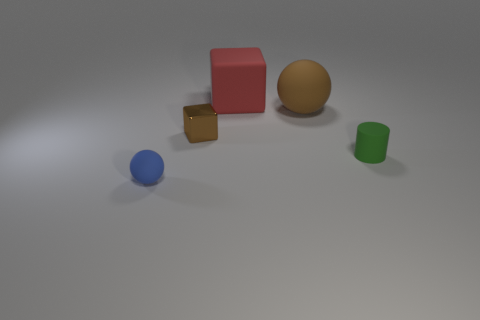Add 3 spheres. How many objects exist? 8 Subtract all red blocks. How many blocks are left? 1 Subtract 1 cubes. How many cubes are left? 1 Subtract all blocks. How many objects are left? 3 Subtract all blue cylinders. Subtract all brown balls. How many cylinders are left? 1 Subtract all tiny blue rubber things. Subtract all big gray spheres. How many objects are left? 4 Add 3 tiny blue things. How many tiny blue things are left? 4 Add 2 tiny green shiny cubes. How many tiny green shiny cubes exist? 2 Subtract 0 green blocks. How many objects are left? 5 